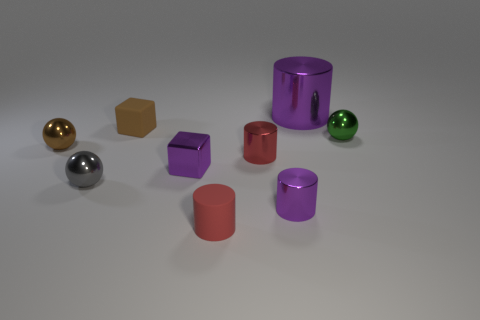What number of purple objects are both on the right side of the matte cylinder and in front of the big purple metal object?
Give a very brief answer. 1. Is the big purple object made of the same material as the tiny purple cylinder?
Your response must be concise. Yes. The brown shiny object that is the same size as the purple block is what shape?
Your response must be concise. Sphere. Is the number of red shiny cylinders greater than the number of small gray cylinders?
Provide a succinct answer. Yes. The small object that is behind the tiny purple cube and in front of the brown metallic object is made of what material?
Give a very brief answer. Metal. How many other objects are there of the same material as the tiny purple cylinder?
Provide a short and direct response. 6. How many other blocks have the same color as the small matte cube?
Provide a succinct answer. 0. There is a purple cylinder that is to the left of the cylinder that is behind the tiny cylinder that is behind the purple cube; what size is it?
Offer a terse response. Small. How many metal things are tiny cyan balls or small brown cubes?
Give a very brief answer. 0. There is a tiny brown matte thing; is its shape the same as the tiny shiny thing on the left side of the small gray ball?
Provide a succinct answer. No. 